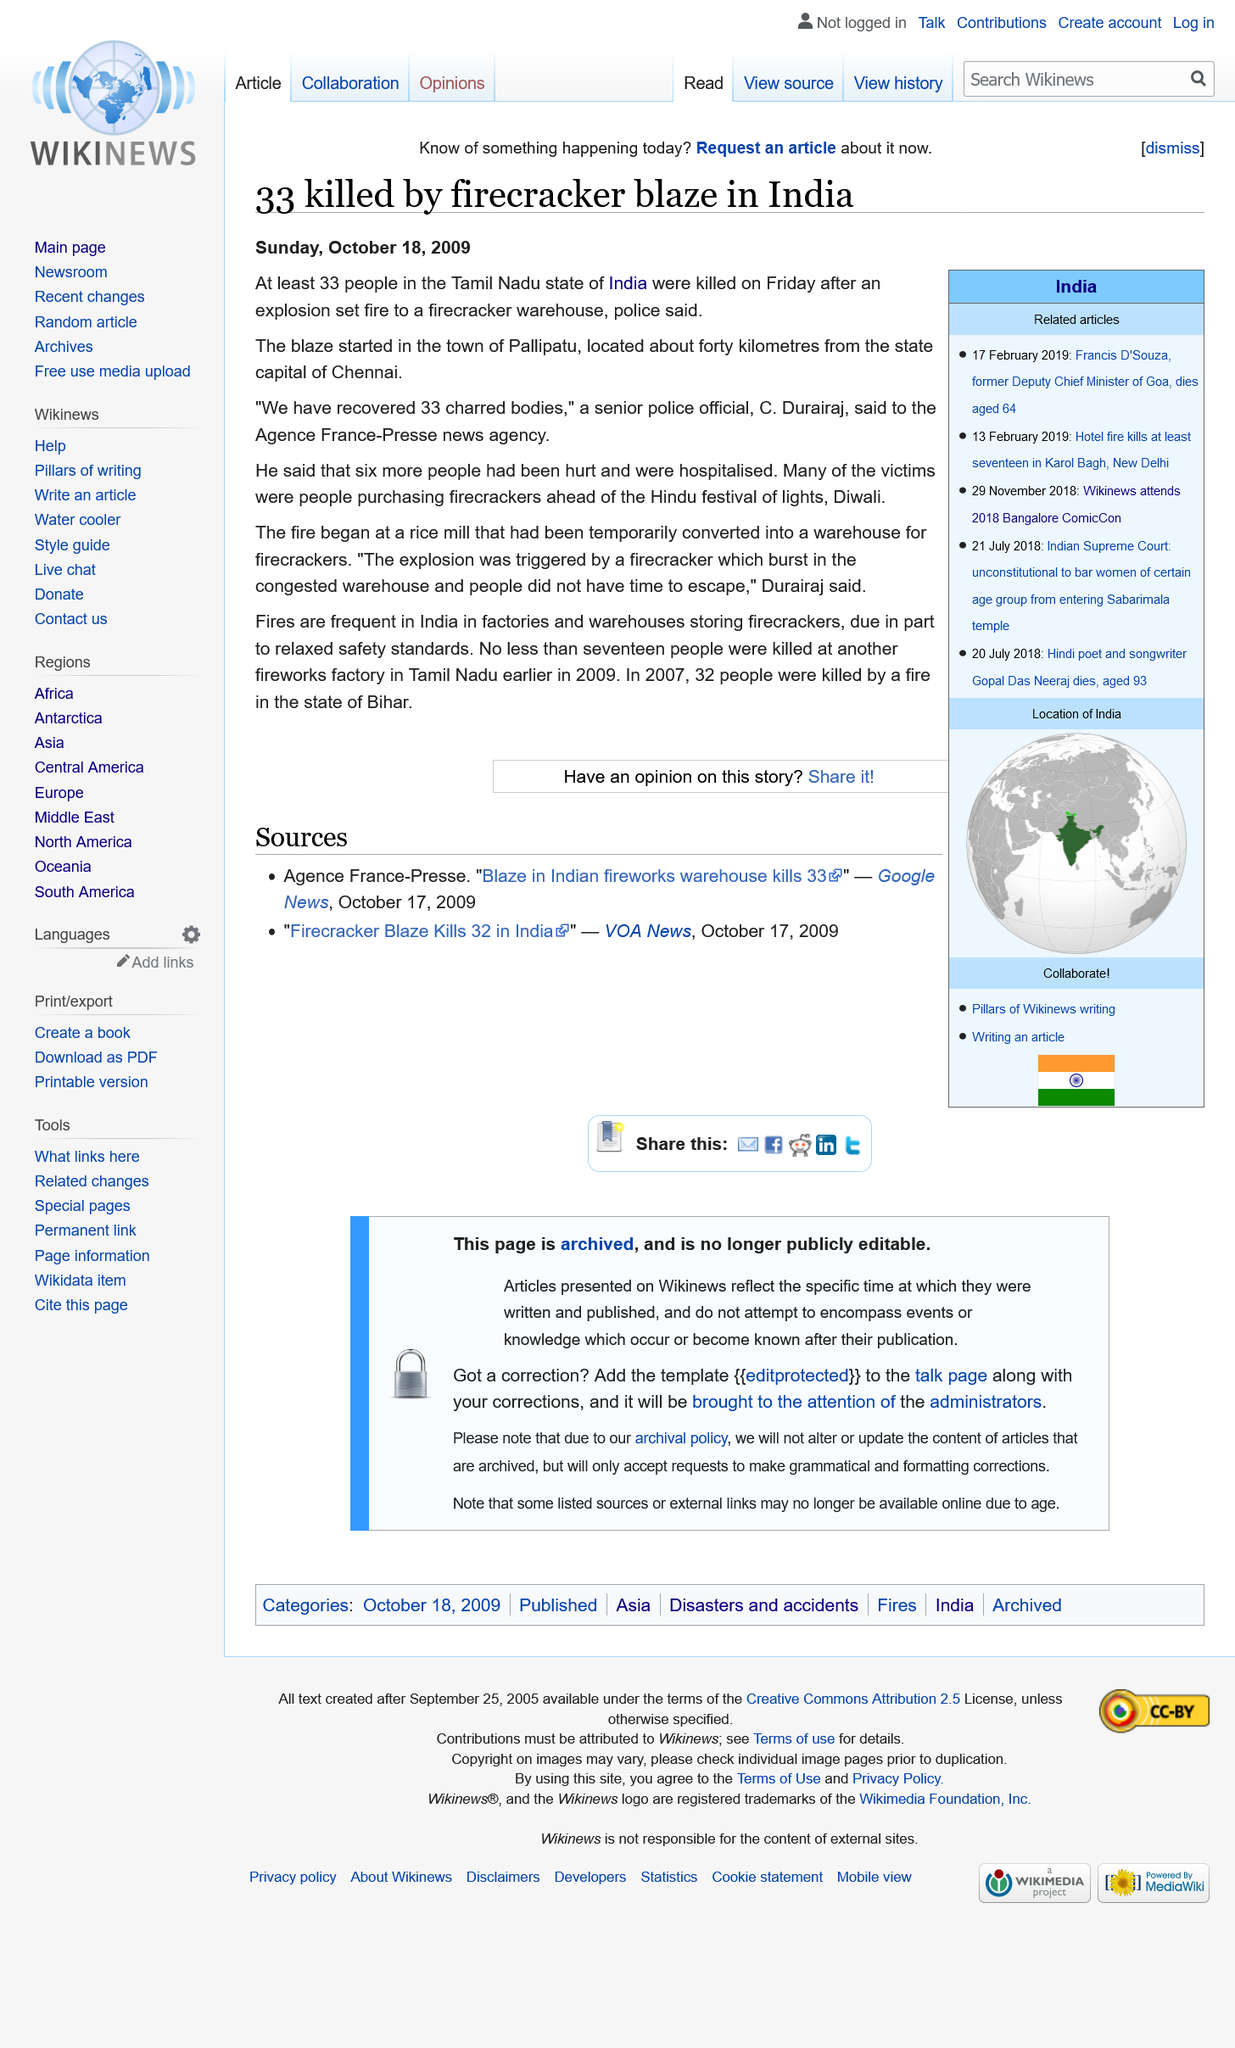List a handful of essential elements in this visual. Thirty-three people lost their lives in a tragic fire at a firecracker warehouse that was caused by an explosion. The article was published on Sunday, October 18th, 2009. Pallipatu, a town located approximately 40 kilometers from the state capital of Chennai, is a distance away from the city. 